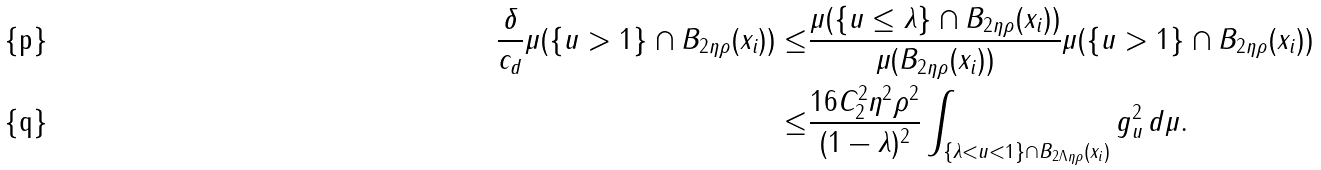<formula> <loc_0><loc_0><loc_500><loc_500>\frac { \delta } { c _ { d } } \mu ( \{ u > 1 \} \cap B _ { 2 \eta \rho } ( x _ { i } ) ) \leq & \frac { \mu ( \{ u \leq \lambda \} \cap B _ { 2 \eta \rho } ( x _ { i } ) ) } { \mu ( B _ { 2 \eta \rho } ( x _ { i } ) ) } \mu ( \{ u > 1 \} \cap B _ { 2 \eta \rho } ( x _ { i } ) ) \\ \leq & \frac { 1 6 C _ { 2 } ^ { 2 } \eta ^ { 2 } \rho ^ { 2 } } { ( 1 - \lambda ) ^ { 2 } } \int _ { \{ \lambda < u < 1 \} \cap B _ { 2 \Lambda \eta \rho } ( x _ { i } ) } g _ { u } ^ { 2 } \, d \mu .</formula> 